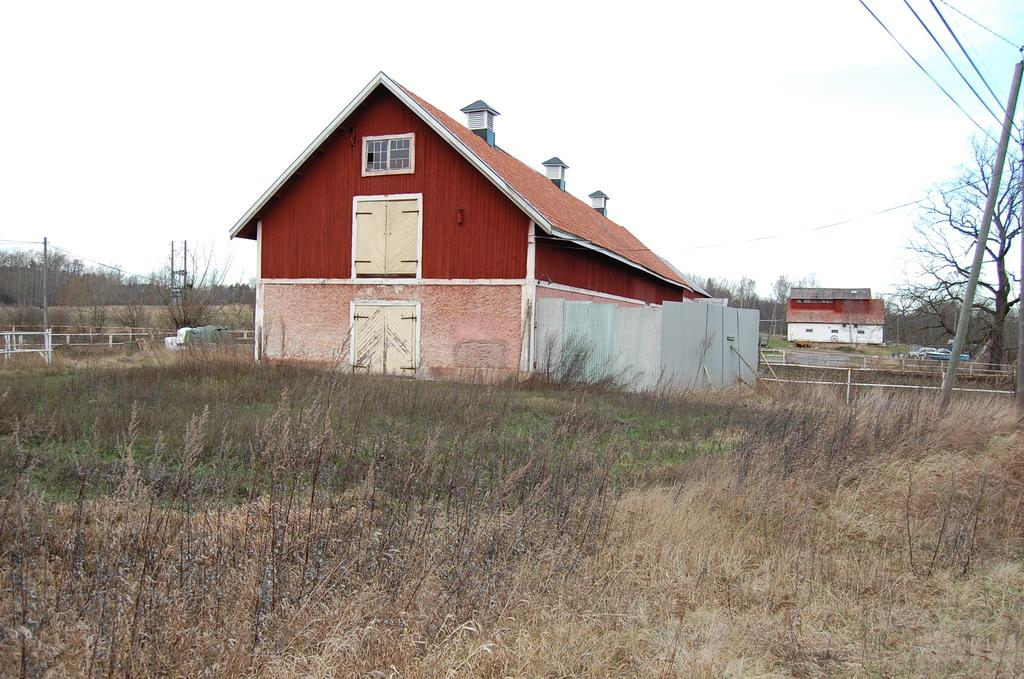What type of vegetation is on the ground in the image? There are dry plants on the ground in the image. What structures can be seen in the image? There are buildings in the image. What other natural elements are present in the image? There are trees in the image. What man-made object is present in the image? There is an electrical wire pole in the image. What is the condition of the sky in the image? The sky is clear in the image. Can you tell me how many cherries are on the electrical wire pole in the image? There are no cherries present on the electrical wire pole or in the image. What type of doctor is examining the trees in the image? There is no doctor present in the image, and the trees are not being examined by anyone. 